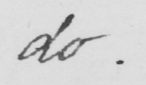Can you read and transcribe this handwriting? do . 